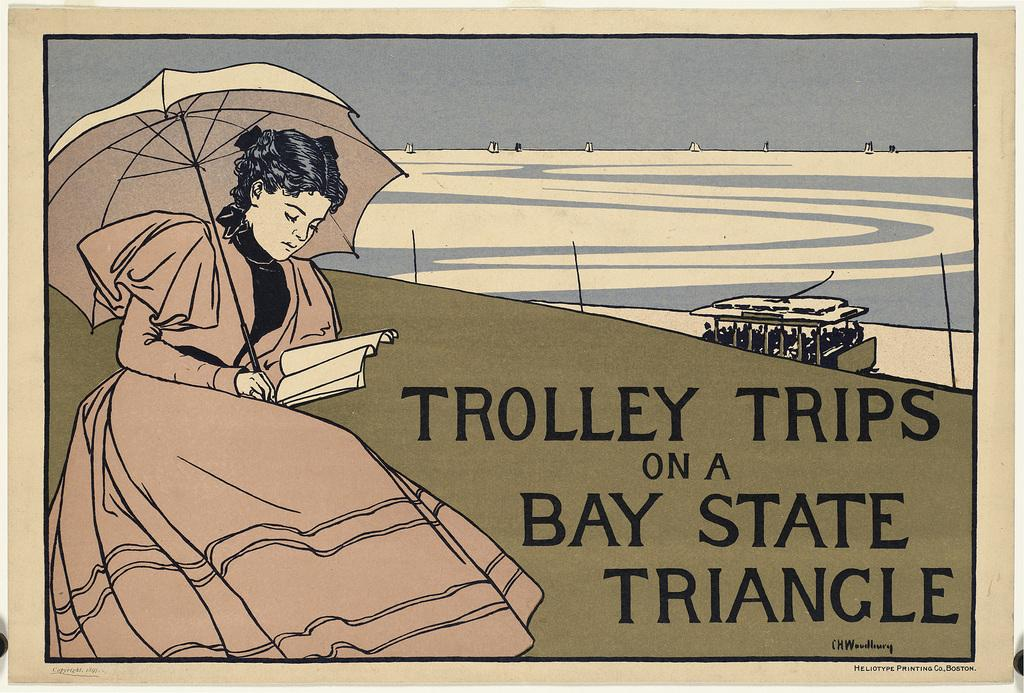Who is the main subject in the foreground of the poster? There is a woman in the foreground of the poster. What is the woman holding in the poster? The woman is holding a book and an umbrella. What can be seen on the right side of the poster? There is text and a boat in the water on the right side of the poster. What is visible at the top of the poster? The sky is visible at the top of the poster. What type of plants can be seen growing in the prison depicted in the poster? There is no prison or plants present in the poster; it features a woman holding a book and an umbrella, text, a boat in the water, and a sky. 